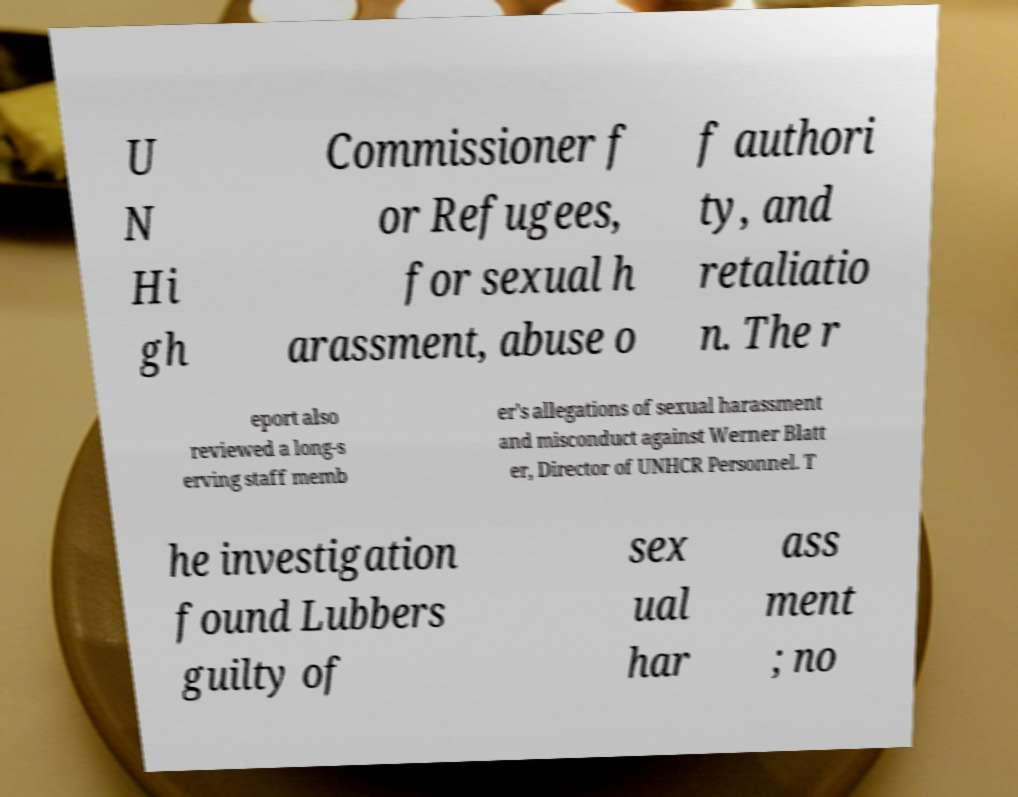I need the written content from this picture converted into text. Can you do that? U N Hi gh Commissioner f or Refugees, for sexual h arassment, abuse o f authori ty, and retaliatio n. The r eport also reviewed a long-s erving staff memb er's allegations of sexual harassment and misconduct against Werner Blatt er, Director of UNHCR Personnel. T he investigation found Lubbers guilty of sex ual har ass ment ; no 